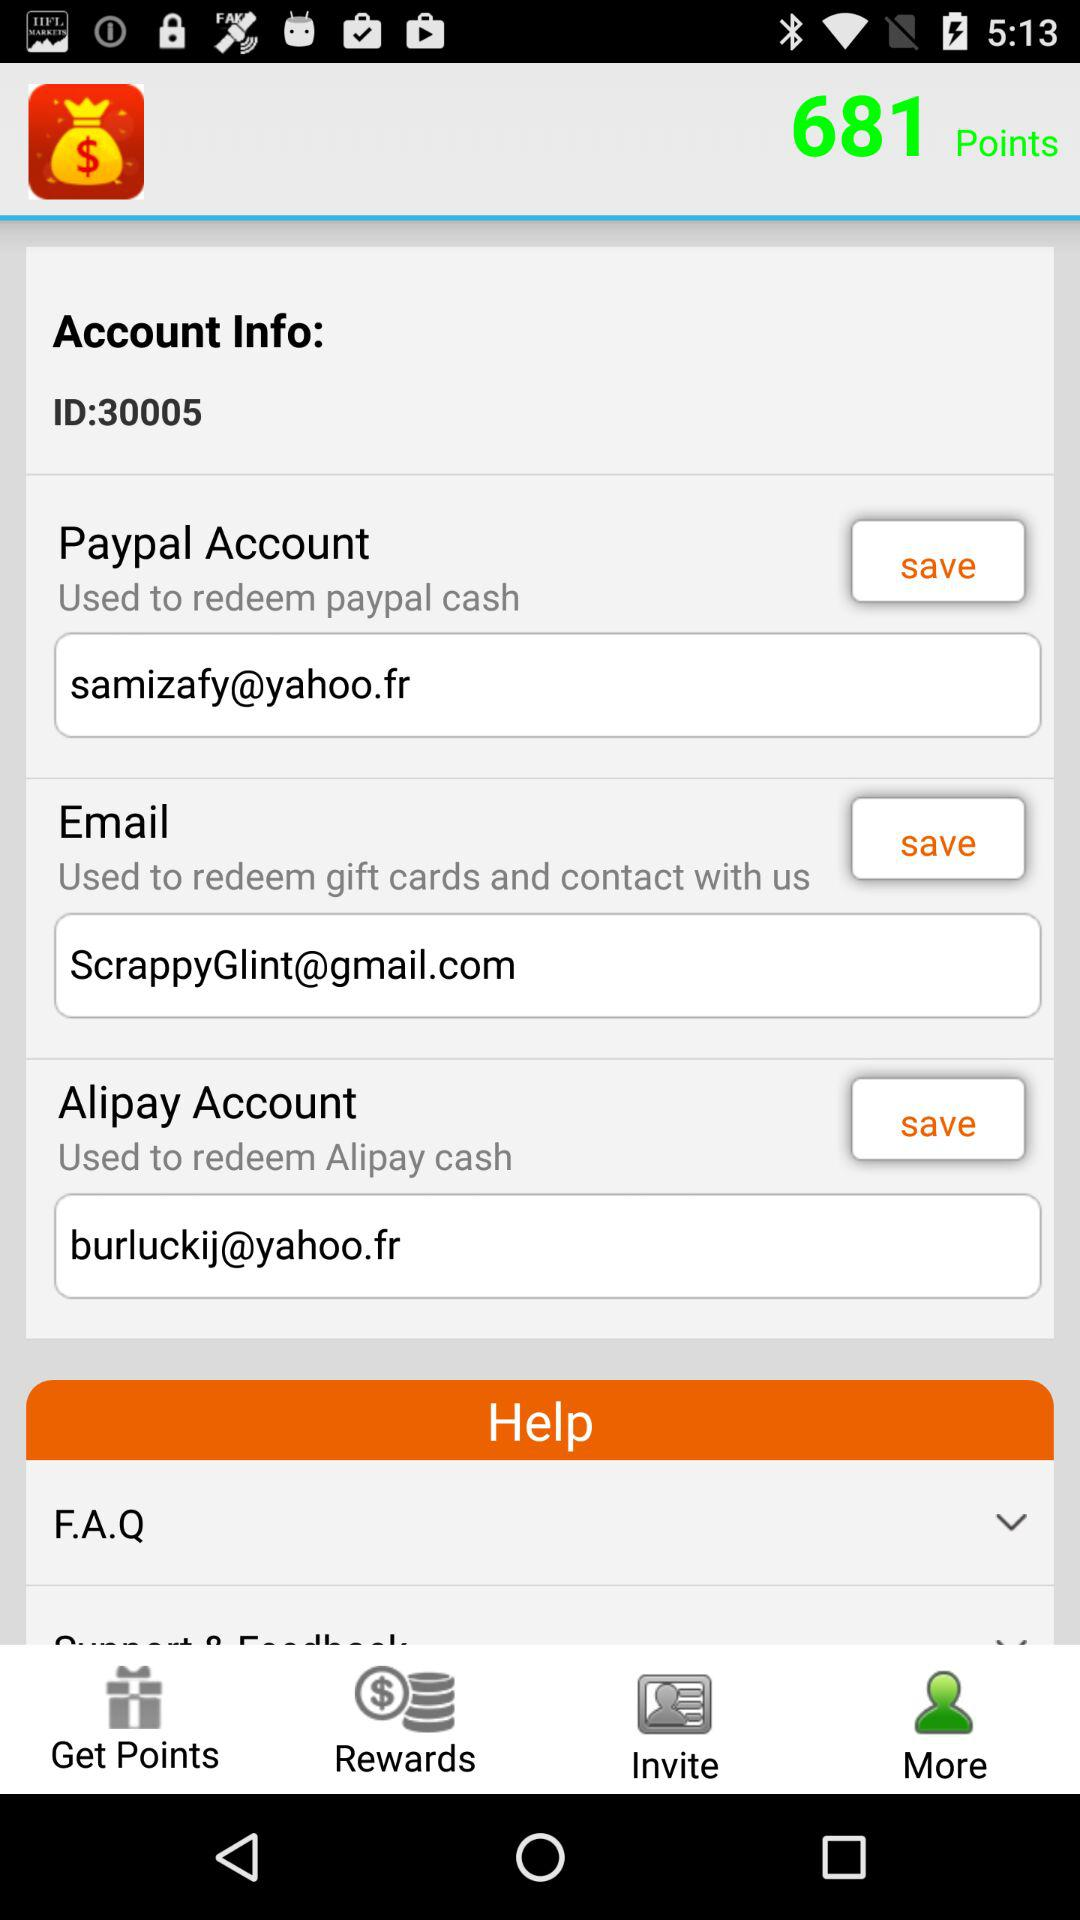What is the email address entered under the "Alipay" account? The email address is burluckij@yahoo.fr. 